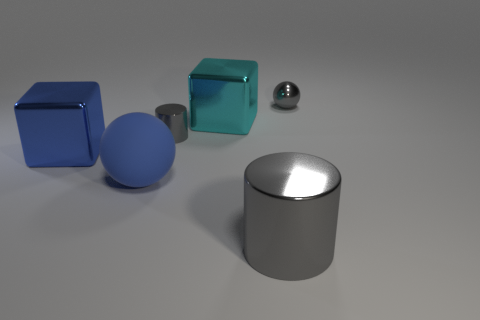Do the ball behind the large blue shiny thing and the tiny cylinder that is behind the large blue block have the same material?
Offer a terse response. Yes. Is there anything else that has the same color as the large rubber thing?
Offer a very short reply. Yes. What is the color of the other large object that is the same shape as the blue metal object?
Your answer should be compact. Cyan. How big is the object that is left of the tiny gray metal cylinder and behind the rubber ball?
Ensure brevity in your answer.  Large. There is a gray metal thing left of the large gray metal object; is its shape the same as the large object on the right side of the cyan cube?
Make the answer very short. Yes. What is the shape of the large metallic object that is the same color as the large matte sphere?
Offer a very short reply. Cube. How many tiny objects have the same material as the big gray thing?
Give a very brief answer. 2. The gray thing that is both to the left of the small metal sphere and behind the blue ball has what shape?
Offer a very short reply. Cylinder. Is the material of the tiny gray thing behind the large cyan object the same as the large cyan object?
Your response must be concise. Yes. Are there any other things that have the same material as the big blue sphere?
Provide a short and direct response. No. 